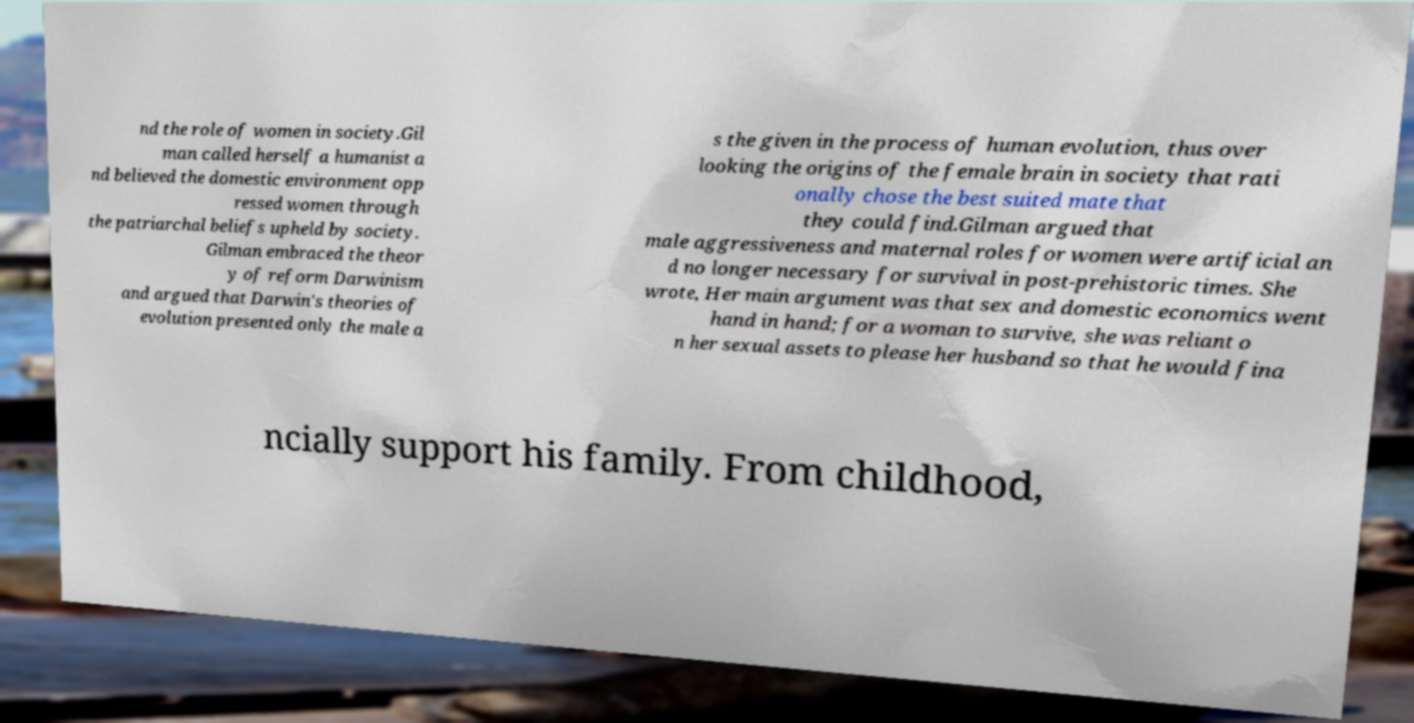Please read and relay the text visible in this image. What does it say? nd the role of women in society.Gil man called herself a humanist a nd believed the domestic environment opp ressed women through the patriarchal beliefs upheld by society. Gilman embraced the theor y of reform Darwinism and argued that Darwin's theories of evolution presented only the male a s the given in the process of human evolution, thus over looking the origins of the female brain in society that rati onally chose the best suited mate that they could find.Gilman argued that male aggressiveness and maternal roles for women were artificial an d no longer necessary for survival in post-prehistoric times. She wrote, Her main argument was that sex and domestic economics went hand in hand; for a woman to survive, she was reliant o n her sexual assets to please her husband so that he would fina ncially support his family. From childhood, 